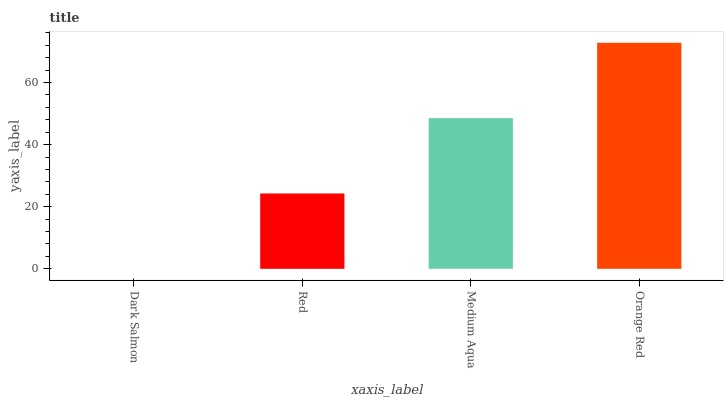Is Dark Salmon the minimum?
Answer yes or no. Yes. Is Orange Red the maximum?
Answer yes or no. Yes. Is Red the minimum?
Answer yes or no. No. Is Red the maximum?
Answer yes or no. No. Is Red greater than Dark Salmon?
Answer yes or no. Yes. Is Dark Salmon less than Red?
Answer yes or no. Yes. Is Dark Salmon greater than Red?
Answer yes or no. No. Is Red less than Dark Salmon?
Answer yes or no. No. Is Medium Aqua the high median?
Answer yes or no. Yes. Is Red the low median?
Answer yes or no. Yes. Is Dark Salmon the high median?
Answer yes or no. No. Is Medium Aqua the low median?
Answer yes or no. No. 